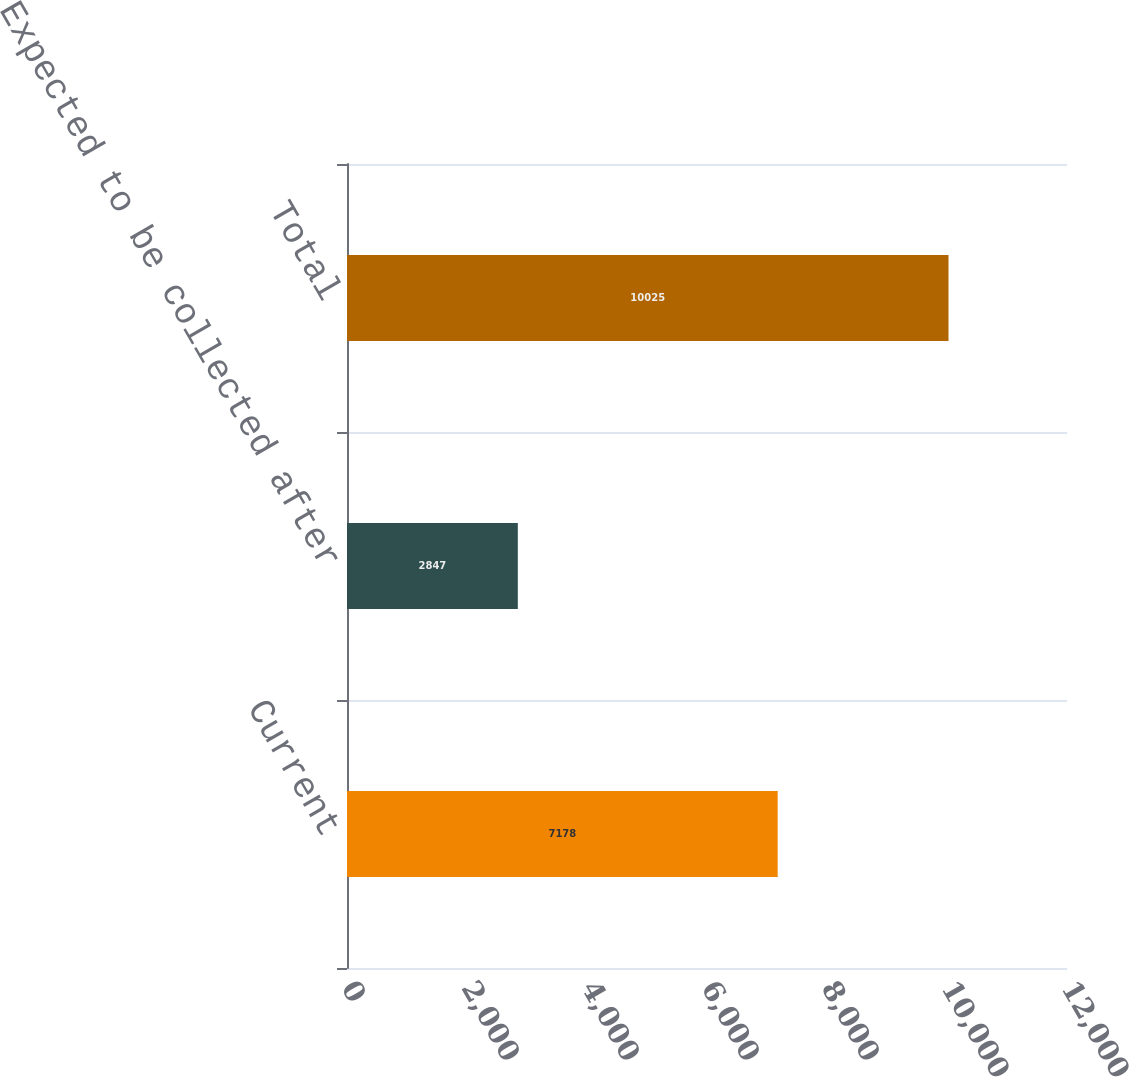<chart> <loc_0><loc_0><loc_500><loc_500><bar_chart><fcel>Current<fcel>Expected to be collected after<fcel>Total<nl><fcel>7178<fcel>2847<fcel>10025<nl></chart> 